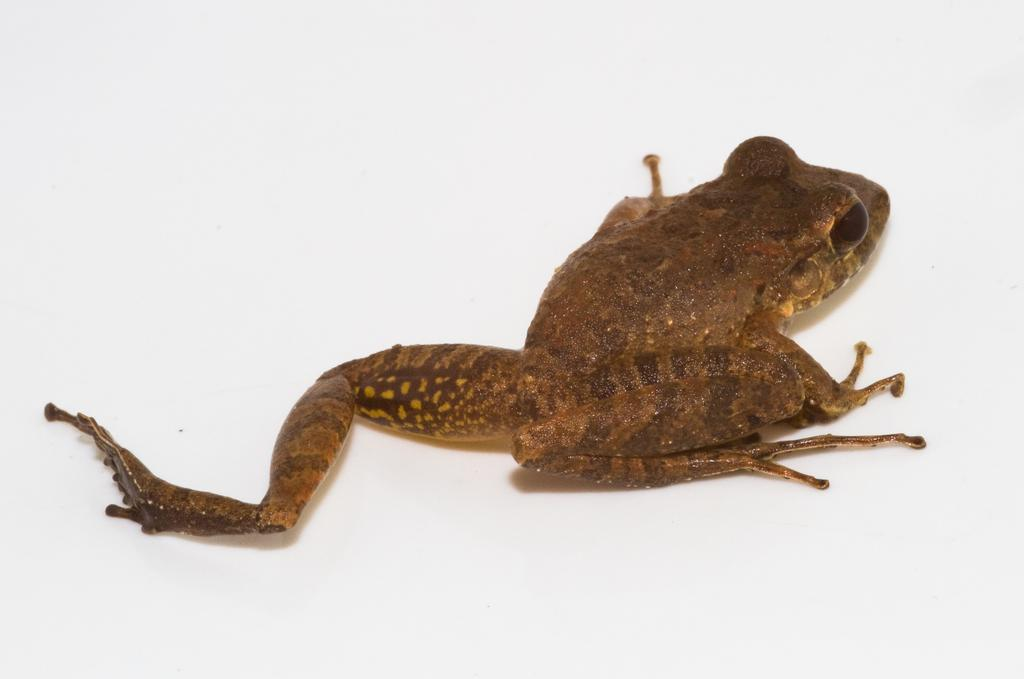What type of animal is in the image? There is a frog in the image. What color is the frog? The frog is brown in color. What is the background or surface the frog is on? The frog is on a white surface. What type of reaction does the frog have to the border in the image? There is no border present in the image, and therefore no reaction from the frog can be observed. 